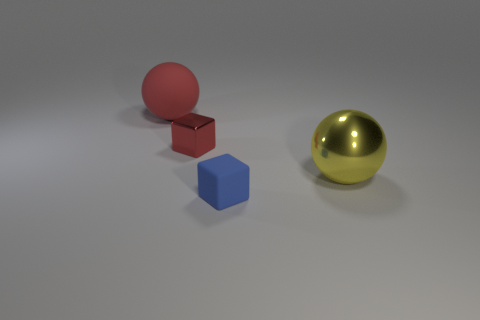Add 3 large metal balls. How many objects exist? 7 Subtract 1 blocks. How many blocks are left? 1 Add 1 large cyan metallic cylinders. How many large cyan metallic cylinders exist? 1 Subtract all yellow balls. How many balls are left? 1 Subtract 0 red cylinders. How many objects are left? 4 Subtract all gray spheres. Subtract all purple cubes. How many spheres are left? 2 Subtract all big yellow rubber balls. Subtract all matte things. How many objects are left? 2 Add 4 big shiny balls. How many big shiny balls are left? 5 